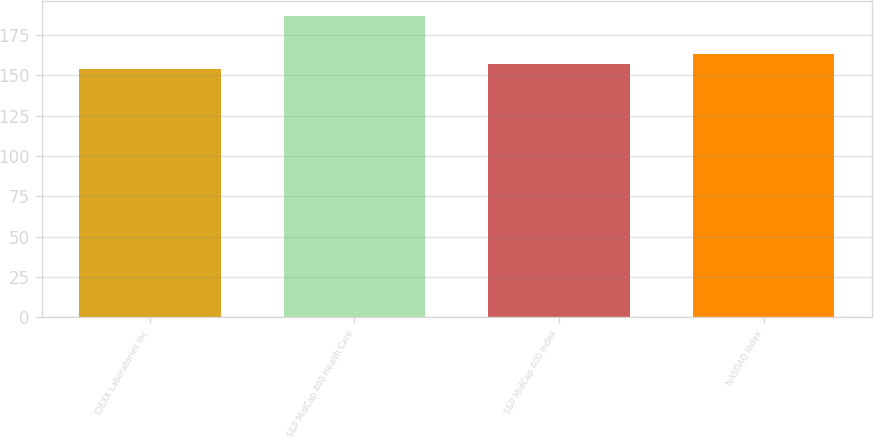<chart> <loc_0><loc_0><loc_500><loc_500><bar_chart><fcel>IDEXX Laboratories Inc<fcel>S&P MidCap 400 Health Care<fcel>S&P MidCap 400 Index<fcel>NASDAQ Index<nl><fcel>153.67<fcel>186.93<fcel>157<fcel>163.21<nl></chart> 